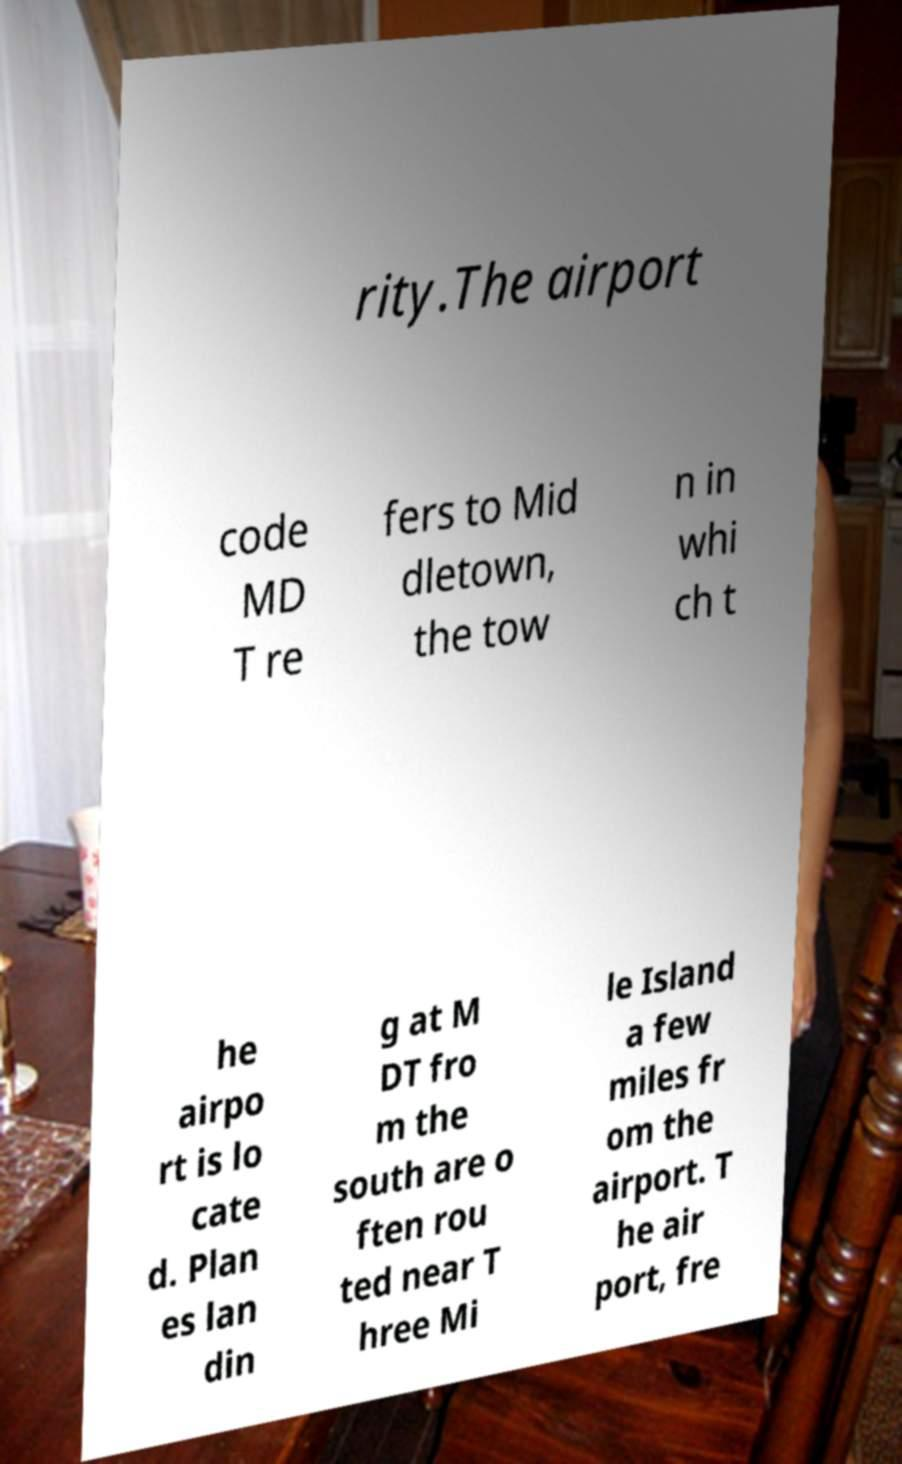There's text embedded in this image that I need extracted. Can you transcribe it verbatim? rity.The airport code MD T re fers to Mid dletown, the tow n in whi ch t he airpo rt is lo cate d. Plan es lan din g at M DT fro m the south are o ften rou ted near T hree Mi le Island a few miles fr om the airport. T he air port, fre 